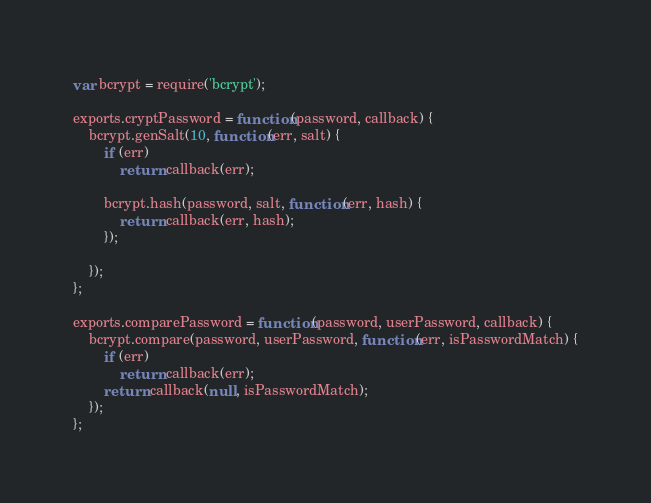Convert code to text. <code><loc_0><loc_0><loc_500><loc_500><_JavaScript_>var bcrypt = require('bcrypt');

exports.cryptPassword = function(password, callback) {
    bcrypt.genSalt(10, function(err, salt) {
        if (err) 
            return callback(err);

        bcrypt.hash(password, salt, function(err, hash) {
            return callback(err, hash);
        });

    });
};

exports.comparePassword = function(password, userPassword, callback) {
    bcrypt.compare(password, userPassword, function(err, isPasswordMatch) {
        if (err) 
            return callback(err);
        return callback(null, isPasswordMatch);
    });
};
</code> 